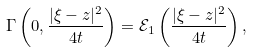Convert formula to latex. <formula><loc_0><loc_0><loc_500><loc_500>\Gamma \left ( 0 , \frac { | \xi - z | ^ { 2 } } { 4 t } \right ) = \mathcal { E } _ { 1 } \left ( \frac { | \xi - z | ^ { 2 } } { 4 t } \right ) ,</formula> 